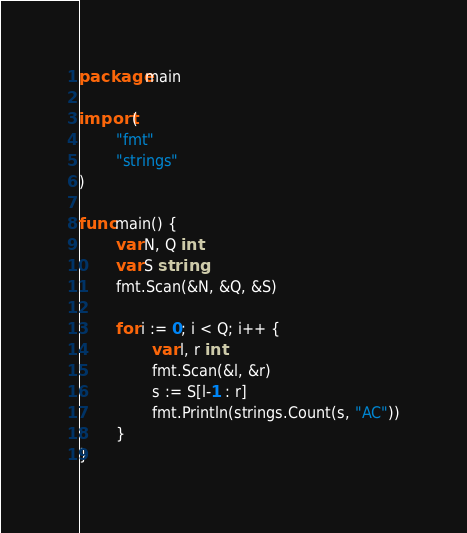Convert code to text. <code><loc_0><loc_0><loc_500><loc_500><_Go_>package main

import (
        "fmt"
        "strings"
)

func main() {
        var N, Q int
        var S string
        fmt.Scan(&N, &Q, &S)

        for i := 0; i < Q; i++ {
                var l, r int
                fmt.Scan(&l, &r)
                s := S[l-1 : r]
                fmt.Println(strings.Count(s, "AC"))
        }
}
</code> 